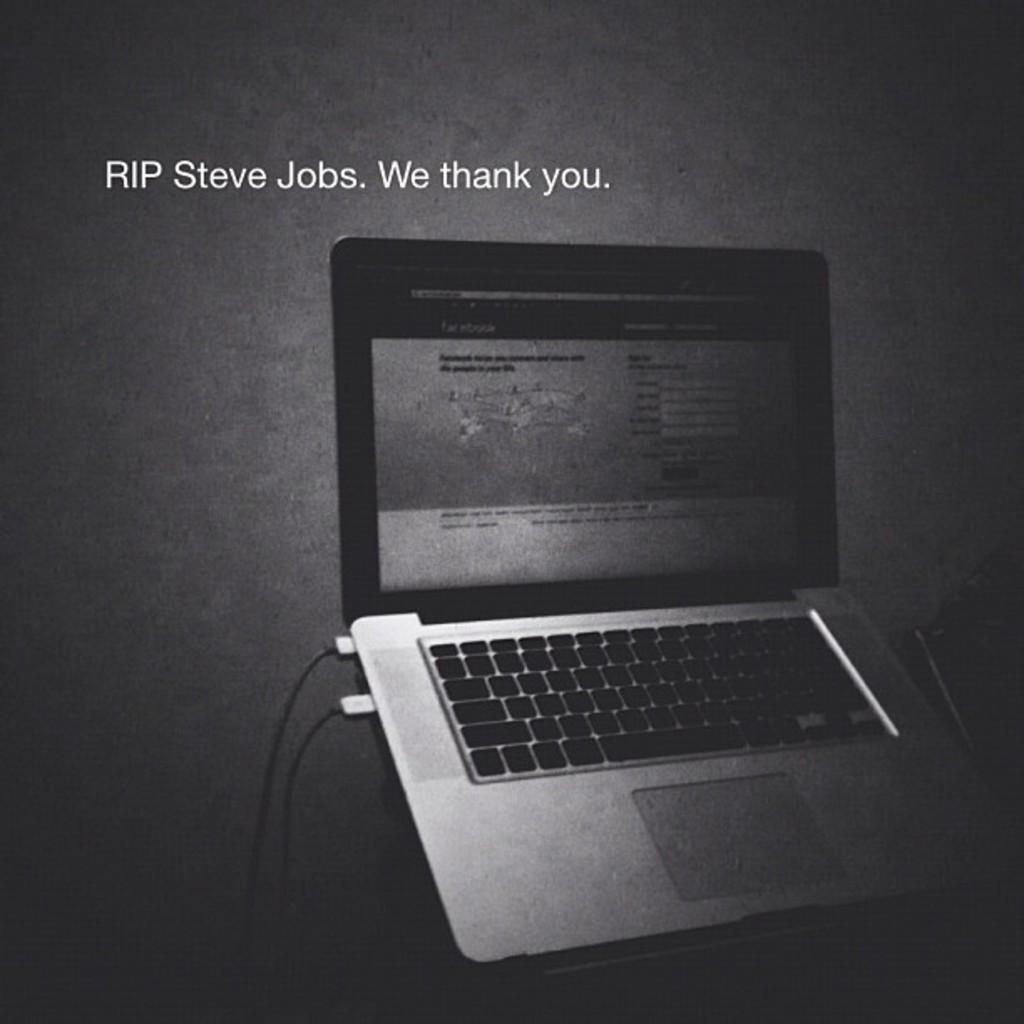<image>
Present a compact description of the photo's key features. a laptop is open and the words say RIP steve jobs 